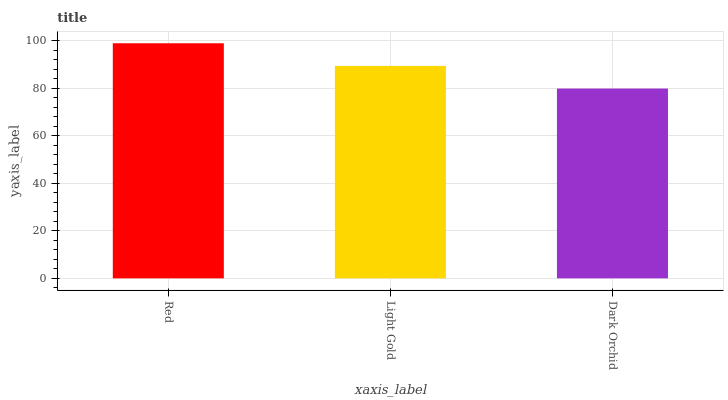Is Light Gold the minimum?
Answer yes or no. No. Is Light Gold the maximum?
Answer yes or no. No. Is Red greater than Light Gold?
Answer yes or no. Yes. Is Light Gold less than Red?
Answer yes or no. Yes. Is Light Gold greater than Red?
Answer yes or no. No. Is Red less than Light Gold?
Answer yes or no. No. Is Light Gold the high median?
Answer yes or no. Yes. Is Light Gold the low median?
Answer yes or no. Yes. Is Dark Orchid the high median?
Answer yes or no. No. Is Red the low median?
Answer yes or no. No. 